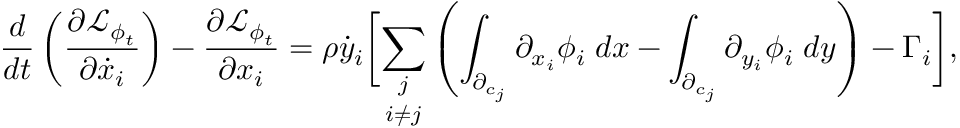Convert formula to latex. <formula><loc_0><loc_0><loc_500><loc_500>\frac { d } { d t } \left ( \frac { \partial \mathcal { L } _ { \phi _ { t } } } { \partial \dot { x } _ { i } } \right ) - \frac { \partial \mathcal { L } _ { \phi _ { t } } } { \partial x _ { i } } = \rho \dot { y } _ { i } \left [ \underset { i \neq j } { \sum _ { j } } \left ( \int _ { \partial _ { c _ { j } } } \partial _ { x _ { i } } \phi _ { i } \, d x - \int _ { \partial _ { c _ { j } } } \partial _ { y _ { i } } \phi _ { i } \, d y \right ) - \Gamma _ { i } \right ] ,</formula> 